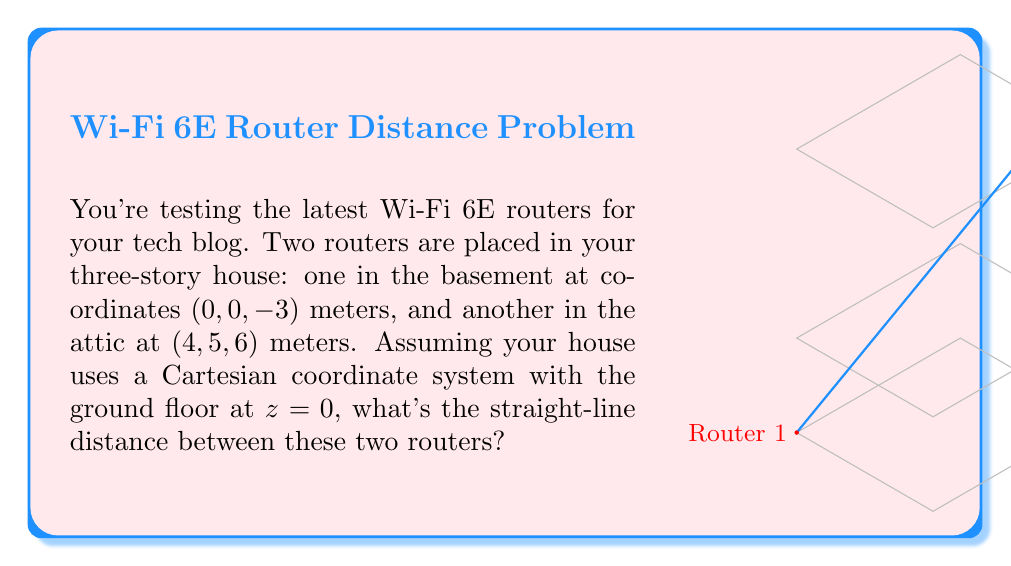Could you help me with this problem? Let's approach this step-by-step:

1) We can use the distance formula in 3D space to solve this problem. The formula is:

   $$d = \sqrt{(x_2-x_1)^2 + (y_2-y_1)^2 + (z_2-z_1)^2}$$

   Where $(x_1, y_1, z_1)$ are the coordinates of the first point and $(x_2, y_2, z_2)$ are the coordinates of the second point.

2) We have:
   Router 1: $(x_1, y_1, z_1) = (0, 0, -3)$
   Router 2: $(x_2, y_2, z_2) = (4, 5, 6)$

3) Let's substitute these into our formula:

   $$d = \sqrt{(4-0)^2 + (5-0)^2 + (6-(-3))^2}$$

4) Simplify inside the parentheses:

   $$d = \sqrt{4^2 + 5^2 + 9^2}$$

5) Calculate the squares:

   $$d = \sqrt{16 + 25 + 81}$$

6) Add up under the square root:

   $$d = \sqrt{122}$$

7) Simplify the square root:

   $$d = 11.0454...$$

8) Rounding to two decimal places:

   $$d \approx 11.05\text{ meters}$$

This is the straight-line distance between the two Wi-Fi routers.
Answer: $11.05\text{ m}$ 